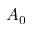<formula> <loc_0><loc_0><loc_500><loc_500>A _ { 0 }</formula> 